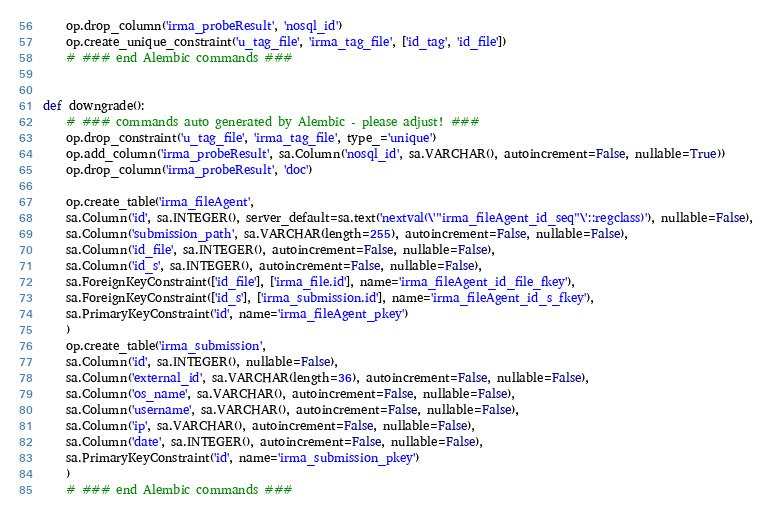<code> <loc_0><loc_0><loc_500><loc_500><_Python_>    op.drop_column('irma_probeResult', 'nosql_id')
    op.create_unique_constraint('u_tag_file', 'irma_tag_file', ['id_tag', 'id_file'])
    # ### end Alembic commands ###


def downgrade():
    # ### commands auto generated by Alembic - please adjust! ###
    op.drop_constraint('u_tag_file', 'irma_tag_file', type_='unique')
    op.add_column('irma_probeResult', sa.Column('nosql_id', sa.VARCHAR(), autoincrement=False, nullable=True))
    op.drop_column('irma_probeResult', 'doc')

    op.create_table('irma_fileAgent',
    sa.Column('id', sa.INTEGER(), server_default=sa.text('nextval(\'"irma_fileAgent_id_seq"\'::regclass)'), nullable=False),
    sa.Column('submission_path', sa.VARCHAR(length=255), autoincrement=False, nullable=False),
    sa.Column('id_file', sa.INTEGER(), autoincrement=False, nullable=False),
    sa.Column('id_s', sa.INTEGER(), autoincrement=False, nullable=False),
    sa.ForeignKeyConstraint(['id_file'], ['irma_file.id'], name='irma_fileAgent_id_file_fkey'),
    sa.ForeignKeyConstraint(['id_s'], ['irma_submission.id'], name='irma_fileAgent_id_s_fkey'),
    sa.PrimaryKeyConstraint('id', name='irma_fileAgent_pkey')
    )
    op.create_table('irma_submission',
    sa.Column('id', sa.INTEGER(), nullable=False),
    sa.Column('external_id', sa.VARCHAR(length=36), autoincrement=False, nullable=False),
    sa.Column('os_name', sa.VARCHAR(), autoincrement=False, nullable=False),
    sa.Column('username', sa.VARCHAR(), autoincrement=False, nullable=False),
    sa.Column('ip', sa.VARCHAR(), autoincrement=False, nullable=False),
    sa.Column('date', sa.INTEGER(), autoincrement=False, nullable=False),
    sa.PrimaryKeyConstraint('id', name='irma_submission_pkey')
    )
    # ### end Alembic commands ###
</code> 